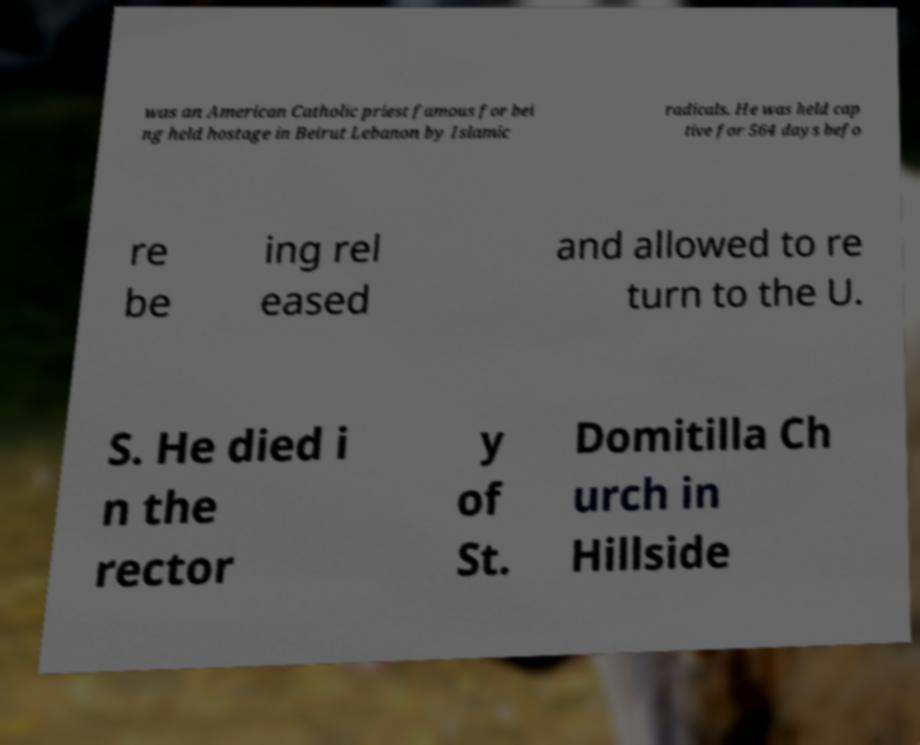I need the written content from this picture converted into text. Can you do that? was an American Catholic priest famous for bei ng held hostage in Beirut Lebanon by Islamic radicals. He was held cap tive for 564 days befo re be ing rel eased and allowed to re turn to the U. S. He died i n the rector y of St. Domitilla Ch urch in Hillside 